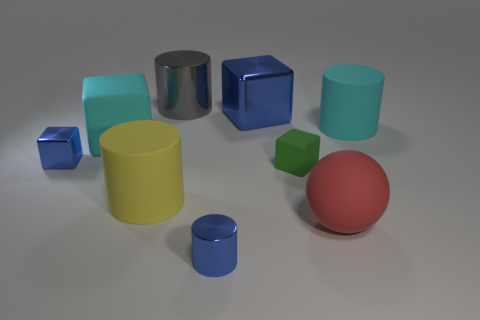Subtract all small blue shiny cylinders. How many cylinders are left? 3 Add 1 big cylinders. How many objects exist? 10 Subtract all green balls. How many blue blocks are left? 2 Subtract all cyan cylinders. How many cylinders are left? 3 Subtract all cylinders. How many objects are left? 5 Subtract 1 yellow cylinders. How many objects are left? 8 Subtract all yellow balls. Subtract all yellow cylinders. How many balls are left? 1 Subtract all cyan objects. Subtract all tiny cylinders. How many objects are left? 6 Add 3 yellow things. How many yellow things are left? 4 Add 6 cyan matte balls. How many cyan matte balls exist? 6 